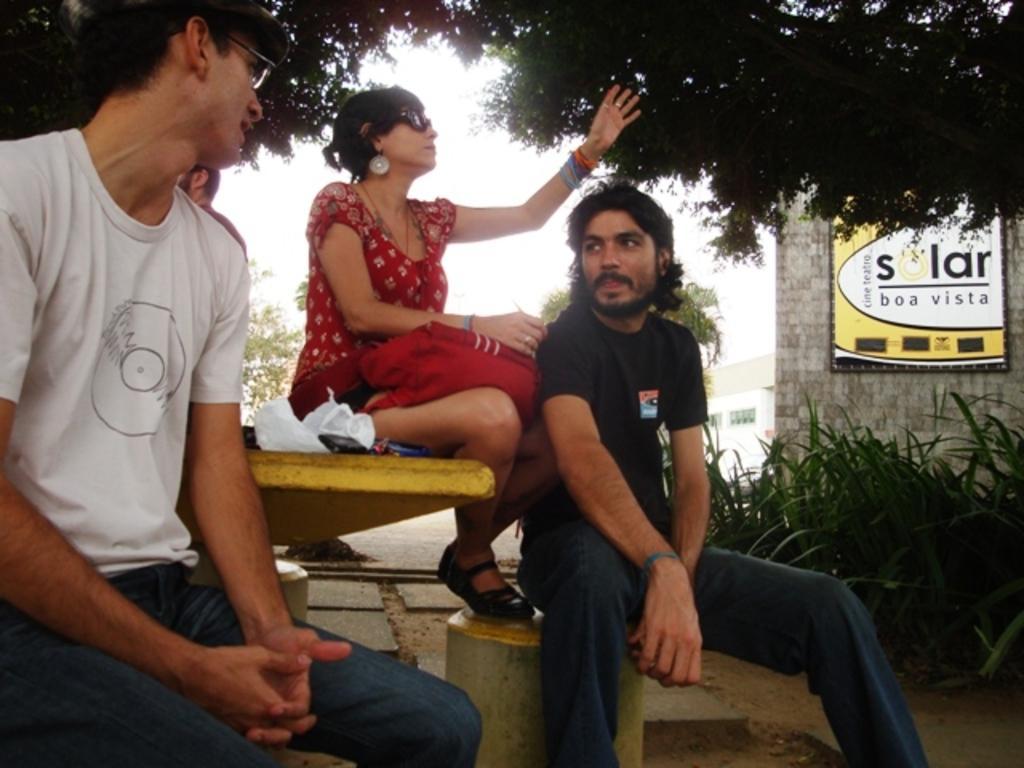Describe this image in one or two sentences. There are three people sitting. This looks like a table with few objects on it. These are the plants. I can see a name board, which is attached to the building wall. These are the trees. I can see a person behind this man. In the background, that looks like a building. 